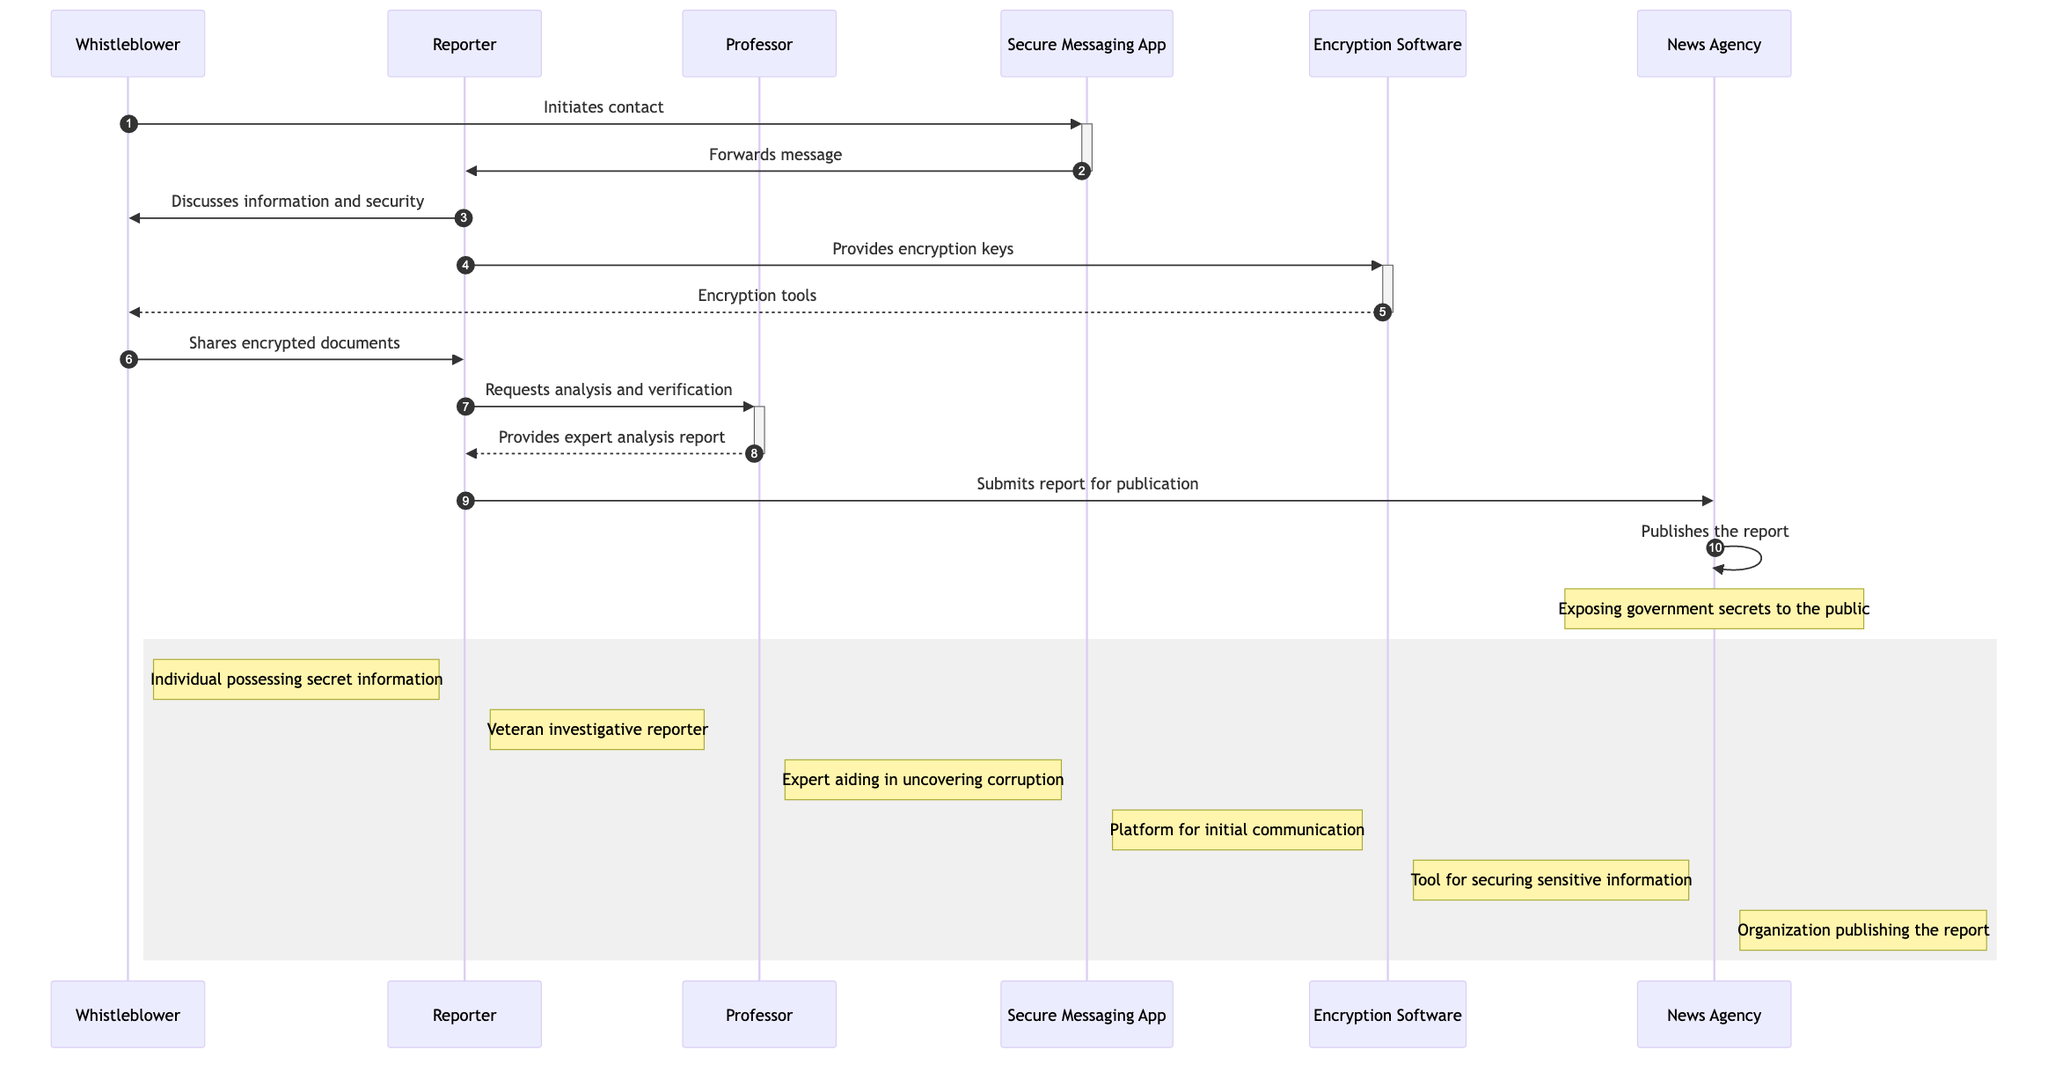What role does the Whistleblower play in this diagram? The Whistleblower is identified as "Individual possessing secret information" in the diagram. This is explicitly mentioned in the participant notes section.
Answer: Individual possessing secret information How many participants are in the diagram? The diagram lists a total of six participants: Whistleblower, Reporter, Professor, Secure Messaging App, Encryption Software, and News Agency. Therefore, the count of participants is six.
Answer: Six What tool did the Reporter provide to the Whistleblower? The Reporter provided "encryption keys" to the Whistleblower as indicated in the message flow where the Reporter communicates with the Encryption Software.
Answer: Encryption keys What does the News Agency do in the last step of the workflow? The News Agency "publishes the report" according to the last message where it interacts with the public, thus disclosing the information.
Answer: Publishes the report What type of communication is initiated by the Whistleblower? The Whistleblower initiates contact via the "Secure Messaging App," which is stated at the beginning of the sequence flow.
Answer: Secure Messaging App What does the Professor provide to the Reporter after analyzing the documents? The Professor provides an "expert analysis report" back to the Reporter, reflecting their assessment of the documents' accuracy and importance.
Answer: Expert analysis report In which step does the Reporter submit the findings? The Reporter submits the findings to the News Agency in the step where the interaction between the Reporter and News Agency is highlighted.
Answer: Submits report for publication What technology is used to secure the communication between the Whistleblower and the Reporter? The technology used to secure communication is "Encryption Software," which the Reporter provides to the Whistleblower for securing their messages and documents.
Answer: Encryption Software What message does the Whistleblower send to the Reporter after discussing security? The Whistleblower shares "encrypted documents" with the Reporter after they discuss security measures to ensure it's safe to proceed.
Answer: Shares encrypted documents 